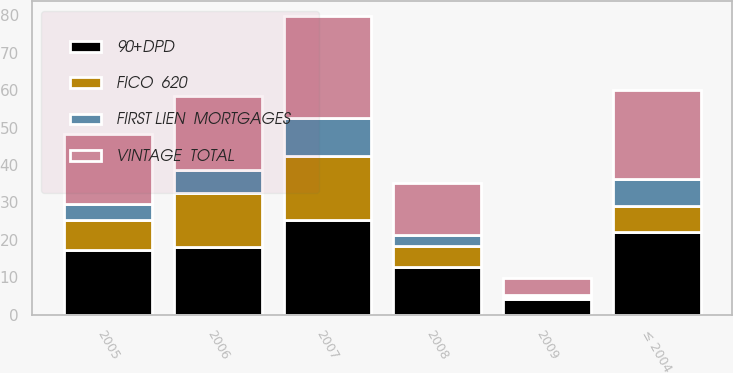<chart> <loc_0><loc_0><loc_500><loc_500><stacked_bar_chart><ecel><fcel>2009<fcel>2008<fcel>2007<fcel>2006<fcel>2005<fcel>≤ 2004<nl><fcel>VINTAGE  TOTAL<fcel>4.5<fcel>13.8<fcel>27.2<fcel>19.5<fcel>18.6<fcel>23.7<nl><fcel>90+DPD<fcel>4.2<fcel>12.8<fcel>25.4<fcel>18.1<fcel>17.4<fcel>22.1<nl><fcel>FICO  620<fcel>0.6<fcel>5.5<fcel>16.9<fcel>14.3<fcel>7.8<fcel>6.9<nl><fcel>FIRST LIEN  MORTGAGES<fcel>0.6<fcel>3<fcel>10.2<fcel>6.4<fcel>4.4<fcel>7.4<nl></chart> 